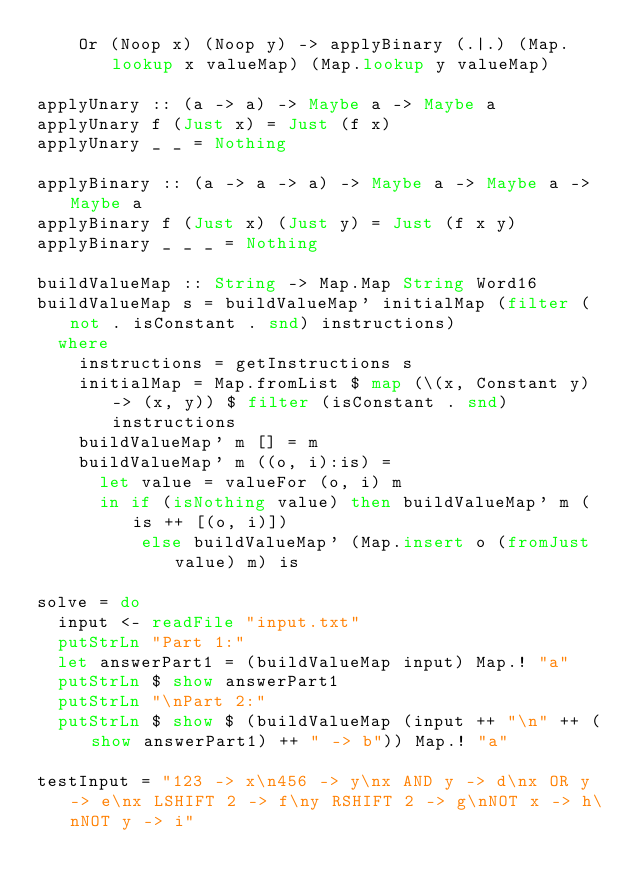Convert code to text. <code><loc_0><loc_0><loc_500><loc_500><_Haskell_>    Or (Noop x) (Noop y) -> applyBinary (.|.) (Map.lookup x valueMap) (Map.lookup y valueMap)

applyUnary :: (a -> a) -> Maybe a -> Maybe a
applyUnary f (Just x) = Just (f x)
applyUnary _ _ = Nothing

applyBinary :: (a -> a -> a) -> Maybe a -> Maybe a -> Maybe a
applyBinary f (Just x) (Just y) = Just (f x y)
applyBinary _ _ _ = Nothing

buildValueMap :: String -> Map.Map String Word16
buildValueMap s = buildValueMap' initialMap (filter (not . isConstant . snd) instructions)
  where
    instructions = getInstructions s
    initialMap = Map.fromList $ map (\(x, Constant y) -> (x, y)) $ filter (isConstant . snd) instructions
    buildValueMap' m [] = m
    buildValueMap' m ((o, i):is) =
      let value = valueFor (o, i) m
      in if (isNothing value) then buildValueMap' m (is ++ [(o, i)])
          else buildValueMap' (Map.insert o (fromJust value) m) is

solve = do
  input <- readFile "input.txt"
  putStrLn "Part 1:"
  let answerPart1 = (buildValueMap input) Map.! "a"
  putStrLn $ show answerPart1
  putStrLn "\nPart 2:"
  putStrLn $ show $ (buildValueMap (input ++ "\n" ++ (show answerPart1) ++ " -> b")) Map.! "a"

testInput = "123 -> x\n456 -> y\nx AND y -> d\nx OR y -> e\nx LSHIFT 2 -> f\ny RSHIFT 2 -> g\nNOT x -> h\nNOT y -> i"</code> 